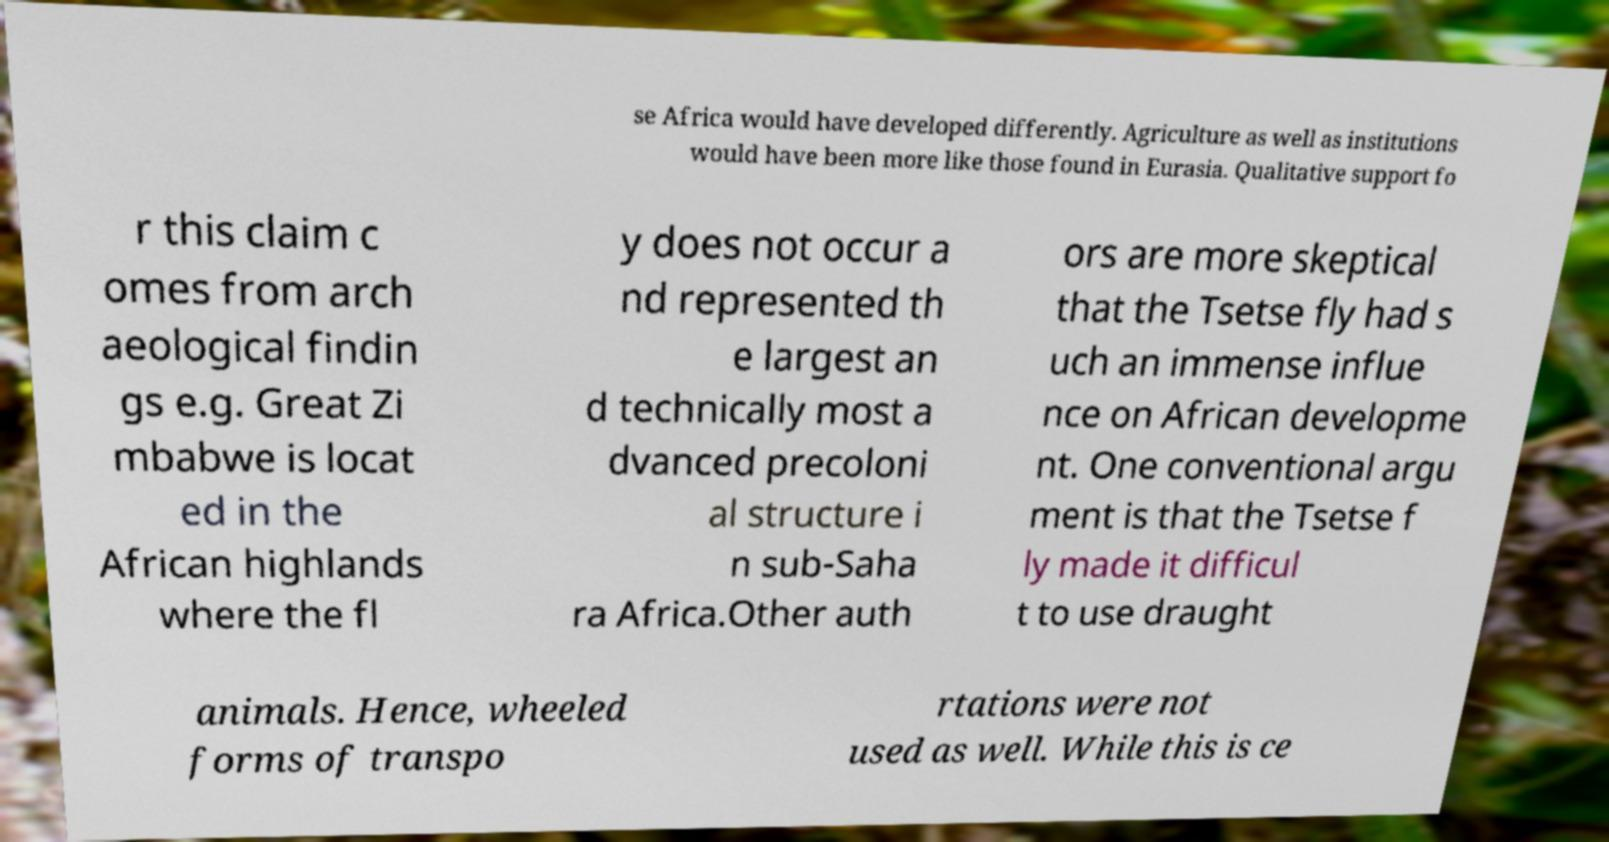Can you read and provide the text displayed in the image?This photo seems to have some interesting text. Can you extract and type it out for me? se Africa would have developed differently. Agriculture as well as institutions would have been more like those found in Eurasia. Qualitative support fo r this claim c omes from arch aeological findin gs e.g. Great Zi mbabwe is locat ed in the African highlands where the fl y does not occur a nd represented th e largest an d technically most a dvanced precoloni al structure i n sub-Saha ra Africa.Other auth ors are more skeptical that the Tsetse fly had s uch an immense influe nce on African developme nt. One conventional argu ment is that the Tsetse f ly made it difficul t to use draught animals. Hence, wheeled forms of transpo rtations were not used as well. While this is ce 